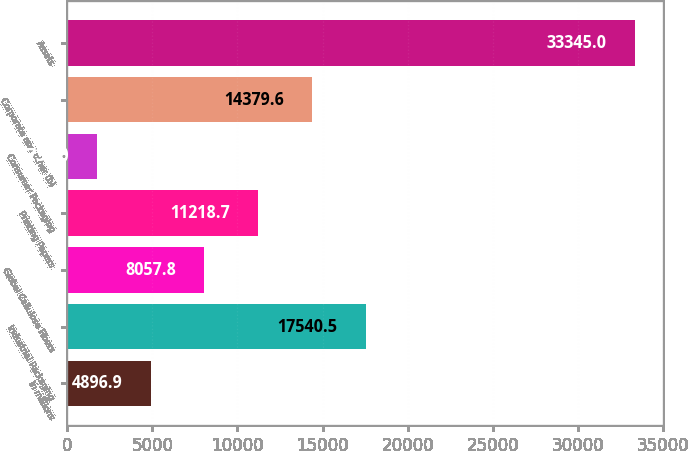<chart> <loc_0><loc_0><loc_500><loc_500><bar_chart><fcel>In millions<fcel>Industrial Packaging<fcel>Global Cellulose Fibers<fcel>Printing Papers<fcel>Consumer Packaging<fcel>Corporate and other (b)<fcel>Assets<nl><fcel>4896.9<fcel>17540.5<fcel>8057.8<fcel>11218.7<fcel>1736<fcel>14379.6<fcel>33345<nl></chart> 